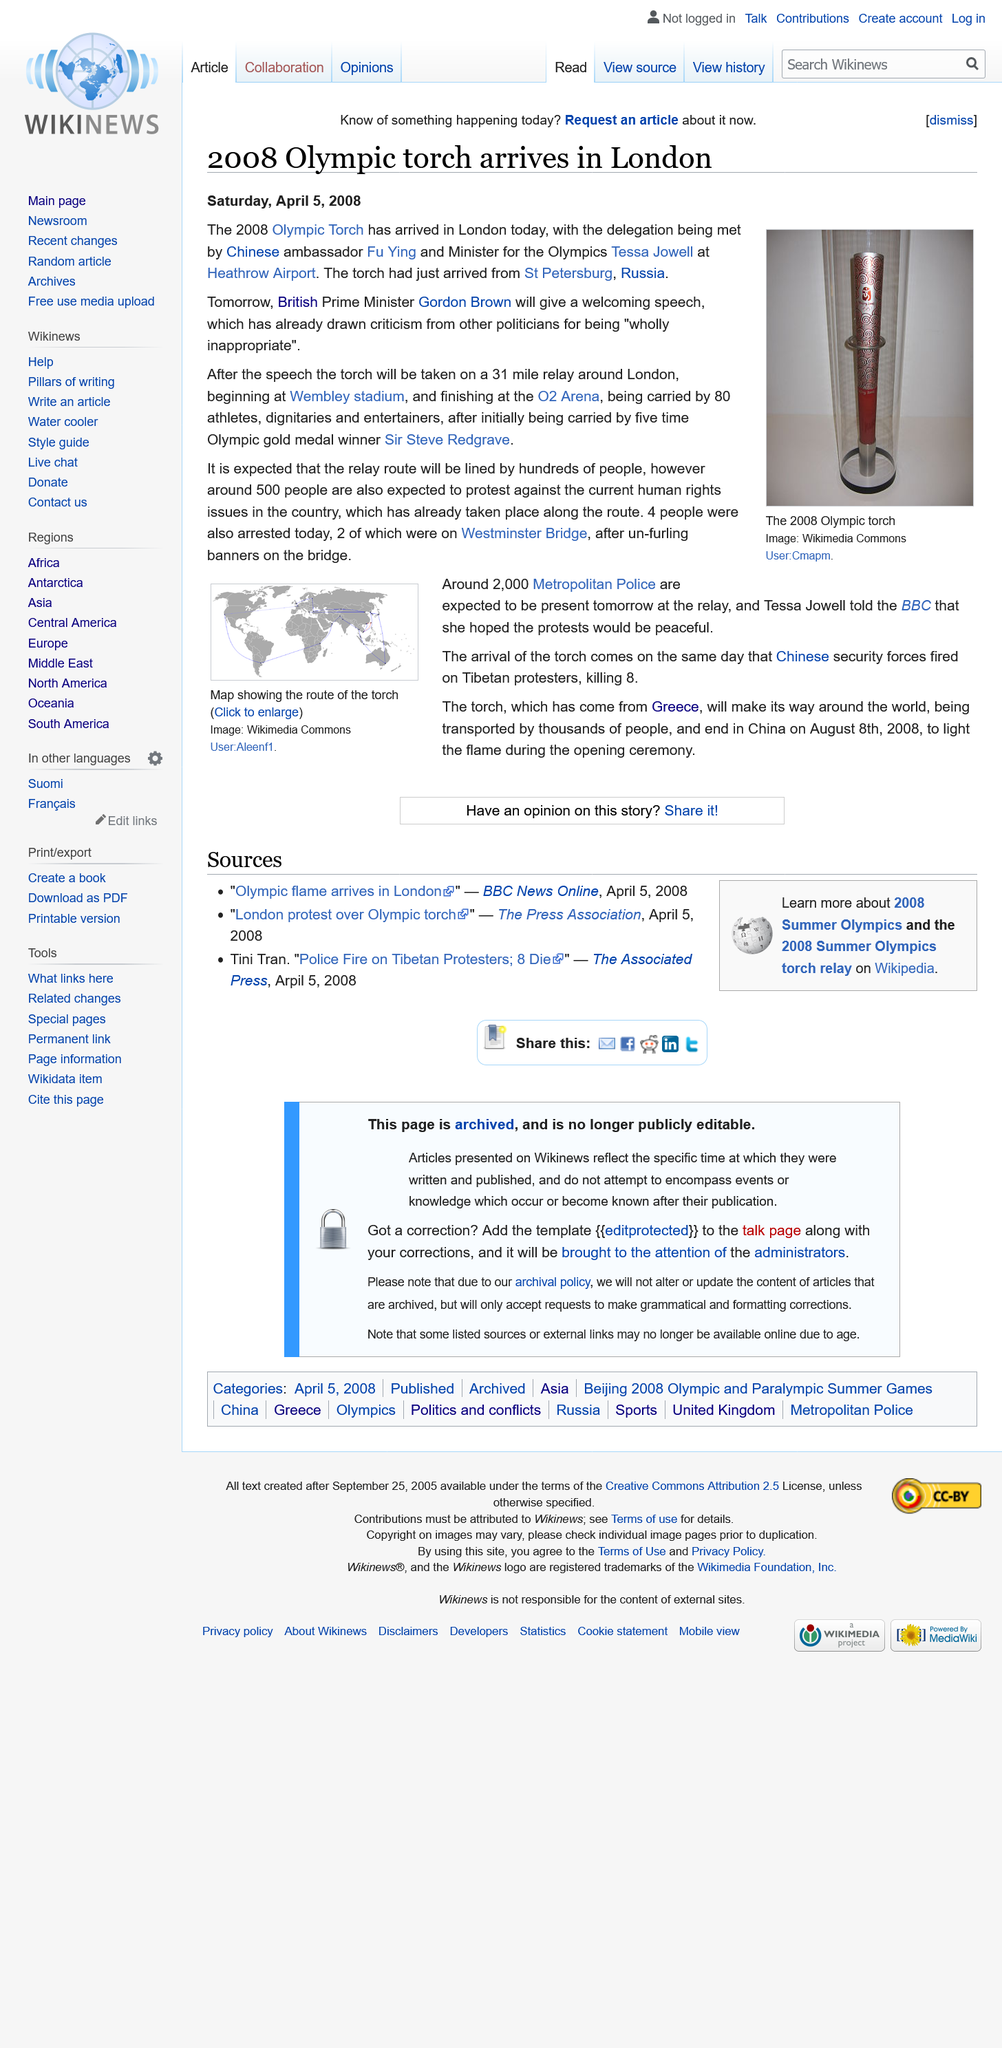Point out several critical features in this image. On April 5, 2008, the 2008 Olympic Torch arrived in London. The current Prime Minister of the United Kingdom is Gordon Brown, who was preceded by Tony Blair. The Chinese ambassador is Fu Ying. 